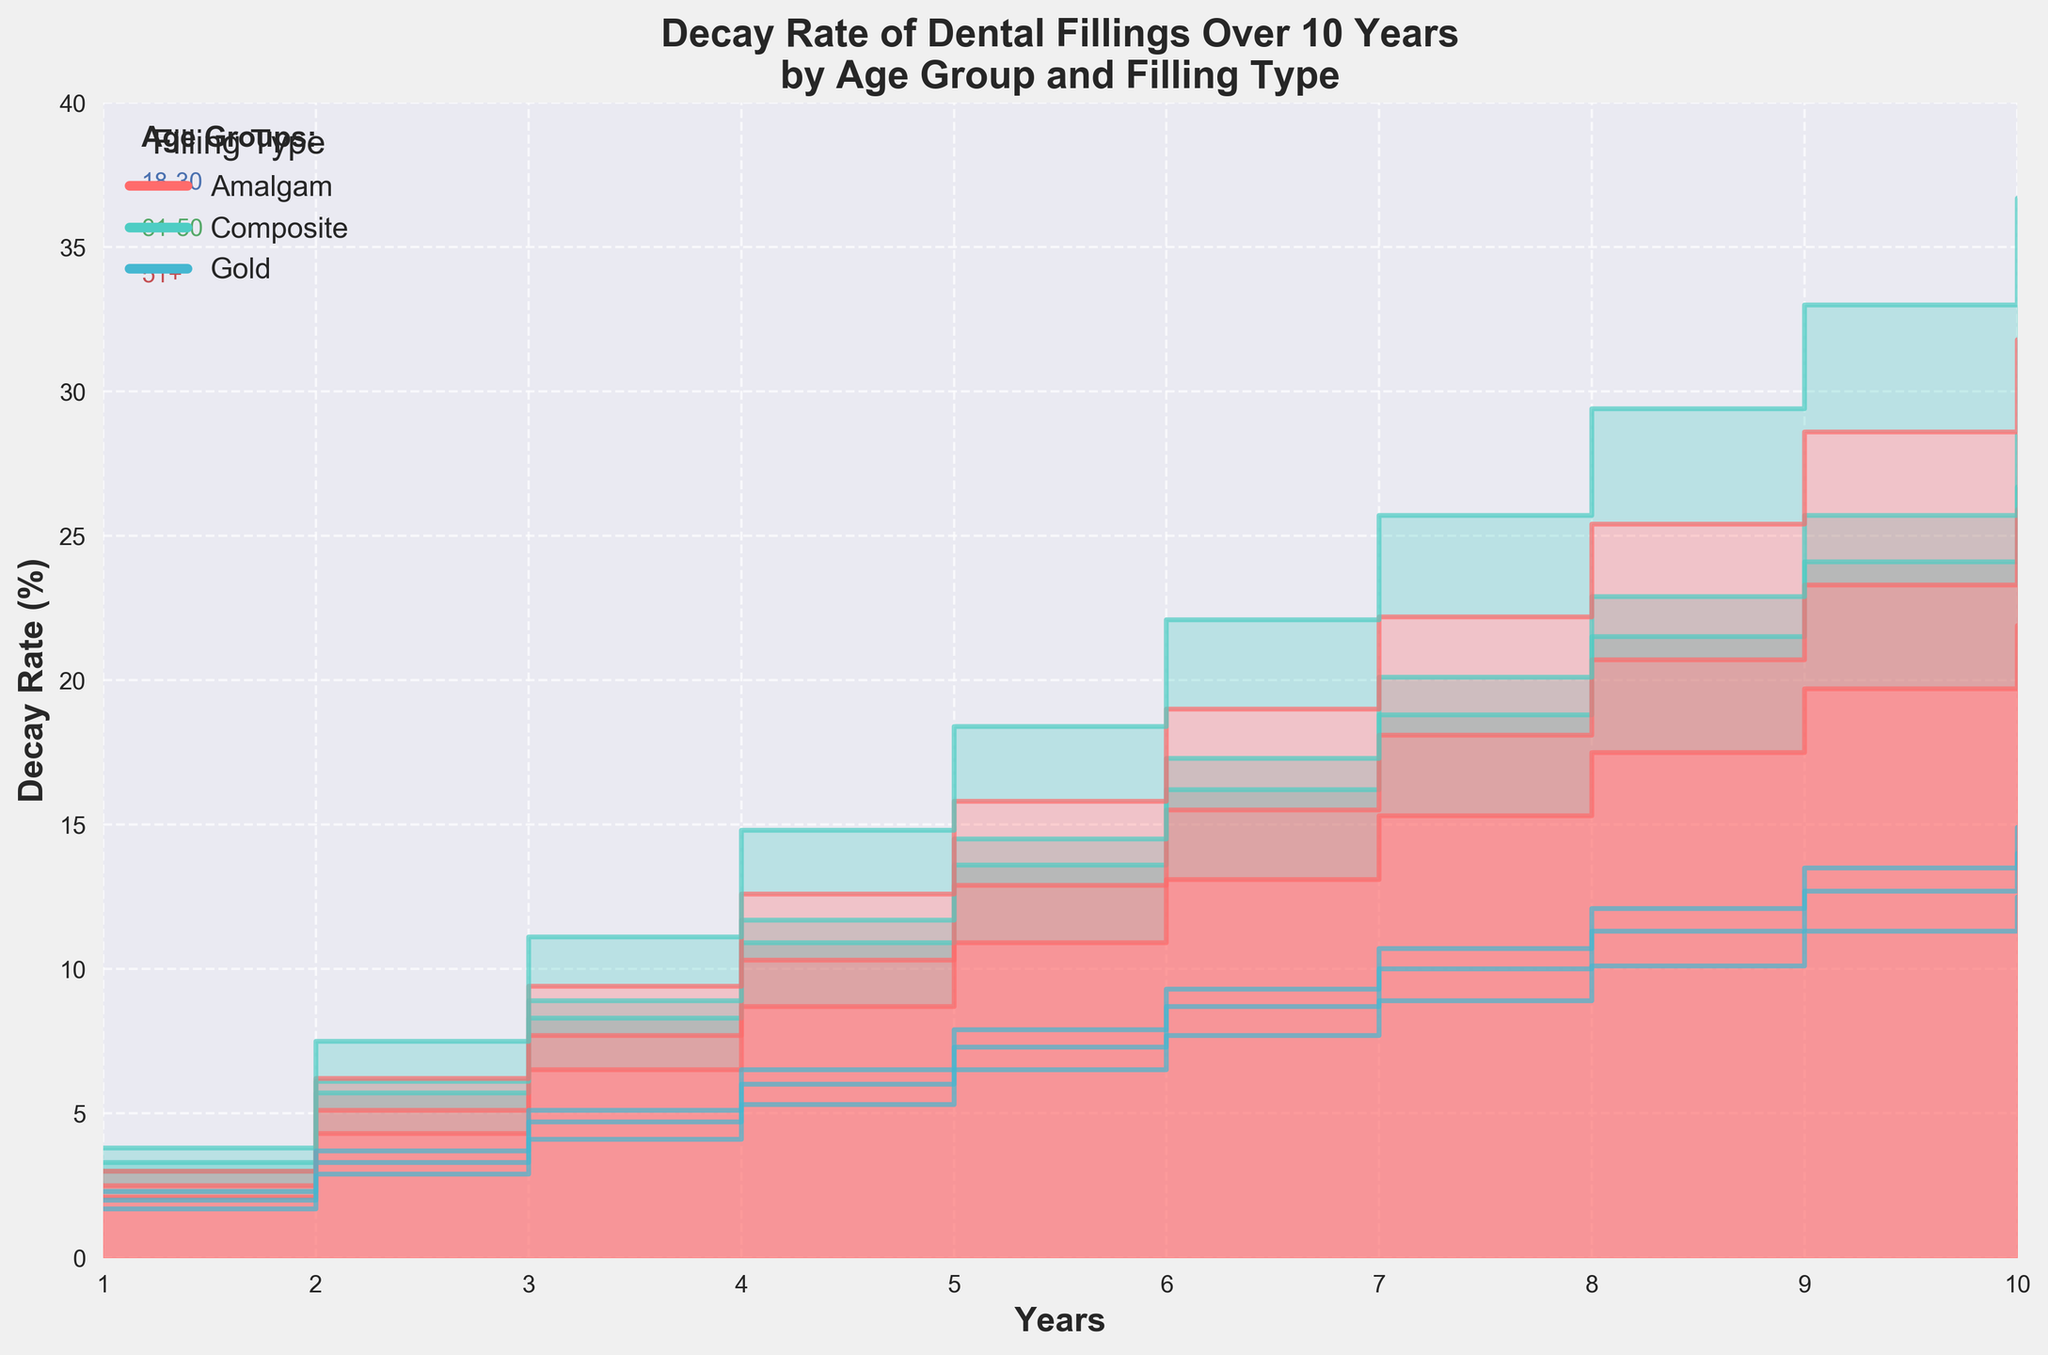What's the title of the chart? The title of the chart is provided at the top of the figure. It is "Decay Rate of Dental Fillings Over 10 Years by Age Group and Filling Type".
Answer: Decay Rate of Dental Fillings Over 10 Years by Age Group and Filling Type What are the labels on the x-axis and y-axis? The x-axis is labeled "Years" and the y-axis is labeled "Decay Rate (%)". These labels indicate what the two axes represent.
Answer: Years, Decay Rate (%) Which age group has the highest decay rate after 10 years for Composite fillings? By looking at the Composite filling data at Year 10, the 51+ age group has the highest decay rate, which is visibly higher than the 18-30 and 31-50 groups.
Answer: 51+ How does the decay rate for Gold fillings compare across the three age groups in the first year? For Year 1, the decay rates for Gold fillings are 1.7% for 18-30, 2.0% for 31-50, and 2.3% for 51+. By comparing these values, we see that the older age groups have slightly higher decay rates.
Answer: 51+ > 31-50 > 18-30 Which filling type shows the highest overall increase in decay rate for the 31-50 age group over the 10 years? By examining the decay rates at Year 1 and Year 10 for the 31-50 age group, Composite fillings show an increase from 3.3% to 28.5%, which is significantly larger than that for Amalgam and Gold.
Answer: Composite Does the decay rate for Amalgam fillings in the 18-30 age group surpass 20% within the 10 years period? Looking at the decay rate for Amalgam fillings from Year 1 to Year 10 for the 18-30 age group, we observe it reaches 21.9% by the 10th year.
Answer: Yes What is the difference in decay rate between Composite and Gold fillings for the 51+ age group at Year 5? For Year 5, the decay rates for Composite and Gold fillings in the 51+ age group are 18.4% and 7.9% respectively. The difference is 18.4 - 7.9 = 10.5.
Answer: 10.5 Among the filling types in the 31-50 age group, which one shows the slowest decay rate progression over 10 years? By comparing decay rates over 10 years for the 31-50 age group, Gold fillings show the slowest progression, increasing from 2.0% to 14.0%.
Answer: Gold Is the decay rate for any filling type in the 18-30 age group above that for Gold fillings in the 51+ age group at Year 6? At Year 6, Composite fillings in the 18-30 age group have a decay rate of 16.2%, which is higher than Gold fillings in the 51+ age group at 9.3%.
Answer: Yes What trend can you observe for Amalgam fillings across all age groups? For all age groups, the trend for Amalgam fillings shows a steady increase in the decay rate over the 10-year period, with older age groups experiencing higher rates.
Answer: Steady increase 